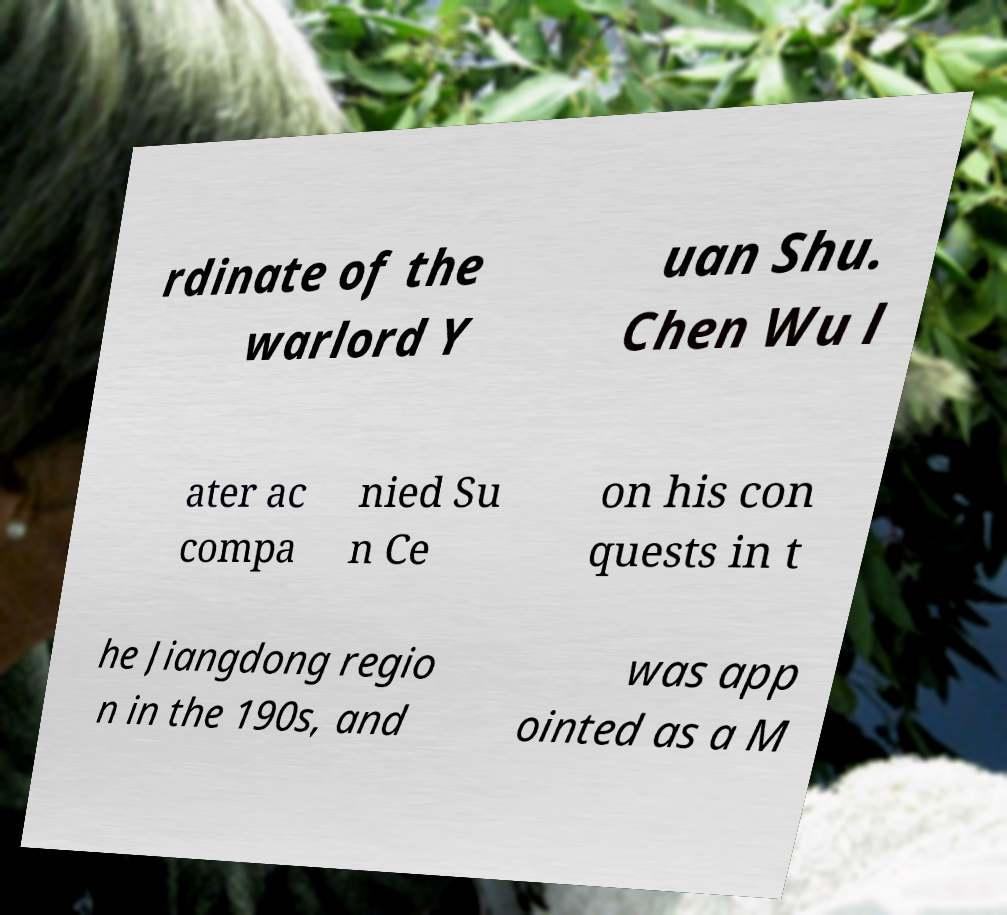What messages or text are displayed in this image? I need them in a readable, typed format. rdinate of the warlord Y uan Shu. Chen Wu l ater ac compa nied Su n Ce on his con quests in t he Jiangdong regio n in the 190s, and was app ointed as a M 